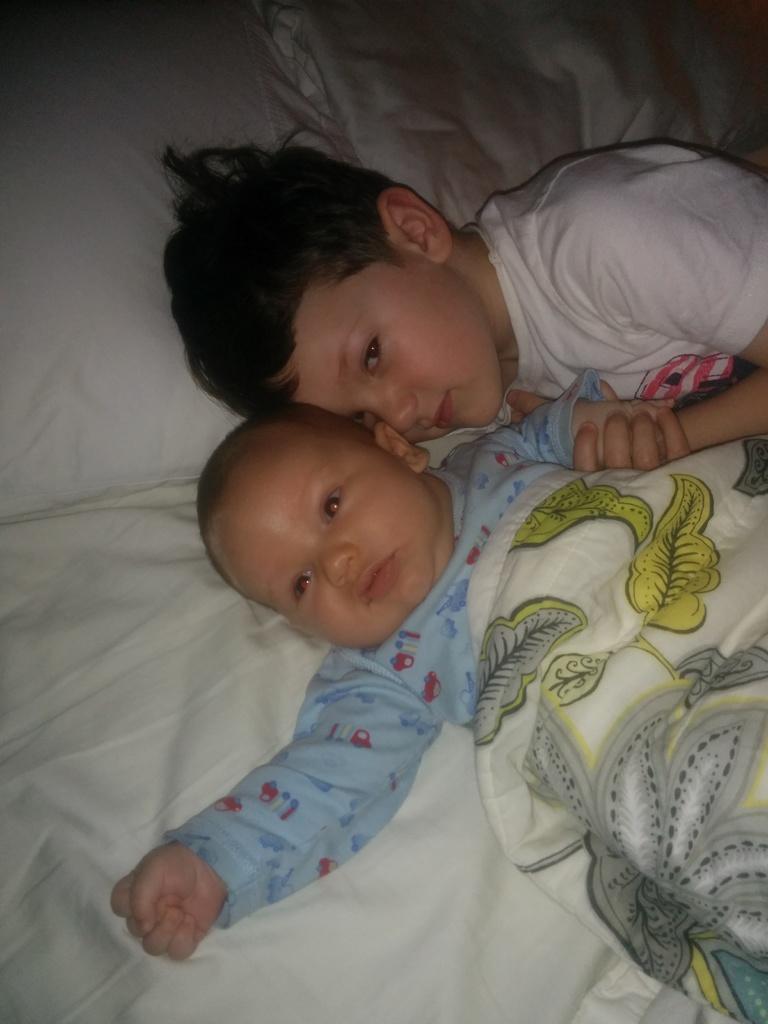Describe this image in one or two sentences. In this picture two children are present on the bed. Where at the left corner pillows are there and at the right corner one boy is in white shirt behind him one baby is in blue dress and a blanket is covered on the baby. 